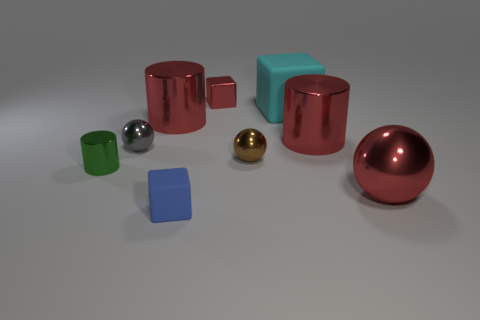Subtract all big shiny cylinders. How many cylinders are left? 1 Subtract all gray cubes. How many red cylinders are left? 2 Add 1 brown matte things. How many objects exist? 10 Subtract all spheres. How many objects are left? 6 Subtract 3 cubes. How many cubes are left? 0 Subtract all small red shiny things. Subtract all small shiny cubes. How many objects are left? 7 Add 3 blue things. How many blue things are left? 4 Add 7 green cylinders. How many green cylinders exist? 8 Subtract 1 red cylinders. How many objects are left? 8 Subtract all brown cubes. Subtract all blue spheres. How many cubes are left? 3 